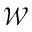<formula> <loc_0><loc_0><loc_500><loc_500>\mathcal { W }</formula> 